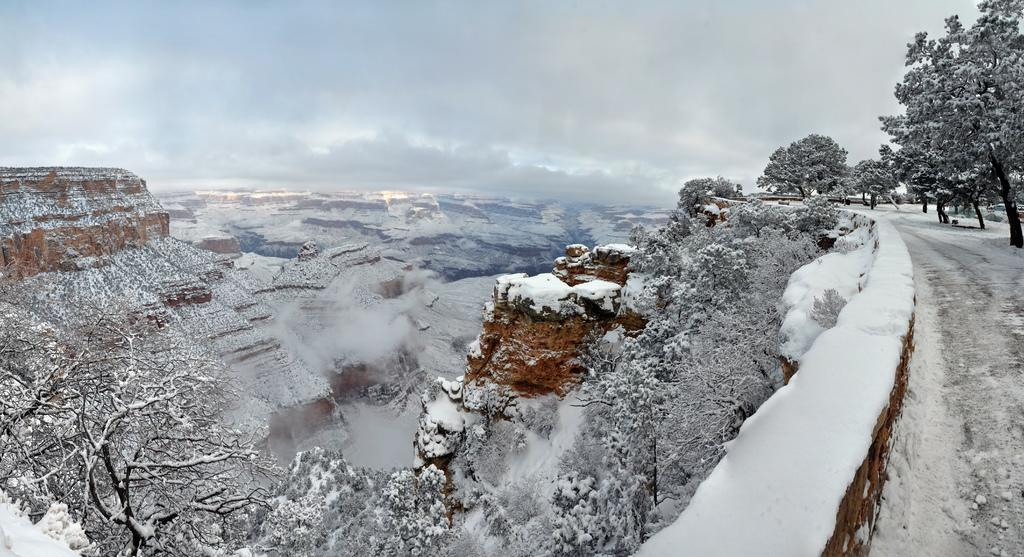What type of landscape can be seen in the image? There are hills in the image. What is the condition of the trees in the image? The trees in the image are covered with snow. What is located on the right side of the image? There is a fence on the right side of the image. What is visible in the image besides the landscape? The sky is visible in the image. How would you describe the sky in the image? The sky appears cloudy in the image. What type of beef is being served in the image? There is no beef present in the image; it features a snowy landscape with hills, trees, a fence, and a cloudy sky. Can you see a cannon in the image? There is no cannon present in the image. 